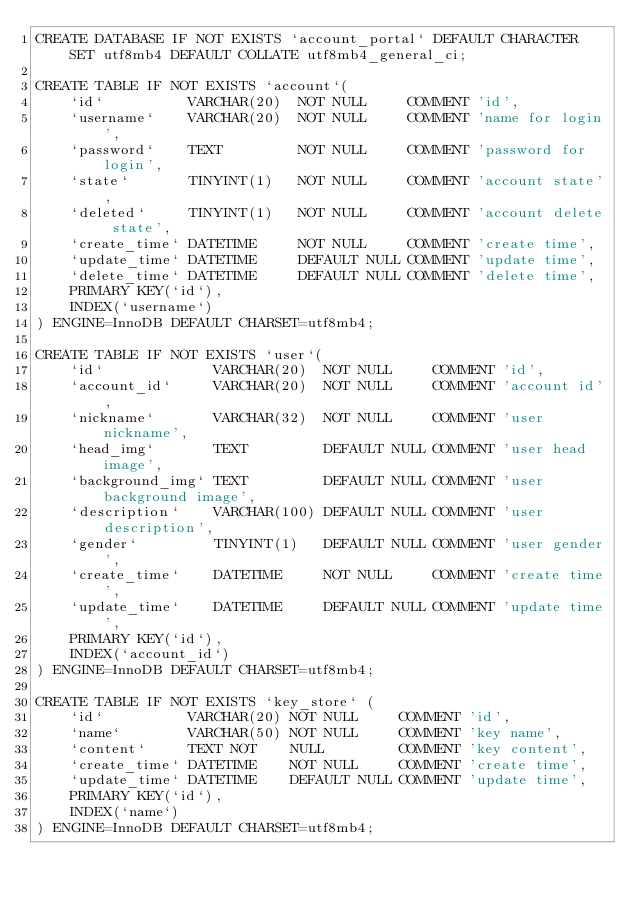<code> <loc_0><loc_0><loc_500><loc_500><_SQL_>CREATE DATABASE IF NOT EXISTS `account_portal` DEFAULT CHARACTER SET utf8mb4 DEFAULT COLLATE utf8mb4_general_ci;

CREATE TABLE IF NOT EXISTS `account`(
    `id`          VARCHAR(20)  NOT NULL     COMMENT 'id',
    `username`    VARCHAR(20)  NOT NULL     COMMENT 'name for login',
    `password`    TEXT         NOT NULL     COMMENT 'password for login',
    `state`       TINYINT(1)   NOT NULL     COMMENT 'account state',
    `deleted`     TINYINT(1)   NOT NULL     COMMENT 'account delete state',
    `create_time` DATETIME     NOT NULL     COMMENT 'create time',
    `update_time` DATETIME     DEFAULT NULL COMMENT 'update time',
    `delete_time` DATETIME     DEFAULT NULL COMMENT 'delete time',
    PRIMARY KEY(`id`),
    INDEX(`username`)
) ENGINE=InnoDB DEFAULT CHARSET=utf8mb4;

CREATE TABLE IF NOT EXISTS `user`(
    `id`             VARCHAR(20)  NOT NULL     COMMENT 'id',
    `account_id`     VARCHAR(20)  NOT NULL     COMMENT 'account id',
    `nickname`       VARCHAR(32)  NOT NULL     COMMENT 'user nickname',
    `head_img`       TEXT         DEFAULT NULL COMMENT 'user head image',
    `background_img` TEXT         DEFAULT NULL COMMENT 'user background image',
    `description`    VARCHAR(100) DEFAULT NULL COMMENT 'user description',
    `gender`         TINYINT(1)   DEFAULT NULL COMMENT 'user gender',
    `create_time`    DATETIME     NOT NULL     COMMENT 'create time',
    `update_time`    DATETIME     DEFAULT NULL COMMENT 'update time',
    PRIMARY KEY(`id`),
    INDEX(`account_id`)
) ENGINE=InnoDB DEFAULT CHARSET=utf8mb4;

CREATE TABLE IF NOT EXISTS `key_store` (
    `id`          VARCHAR(20) NOT NULL     COMMENT 'id',
    `name`        VARCHAR(50) NOT NULL     COMMENT 'key name',
    `content`     TEXT NOT    NULL         COMMENT 'key content',
    `create_time` DATETIME    NOT NULL     COMMENT 'create time',
    `update_time` DATETIME    DEFAULT NULL COMMENT 'update time',
    PRIMARY KEY(`id`),
    INDEX(`name`)
) ENGINE=InnoDB DEFAULT CHARSET=utf8mb4;</code> 